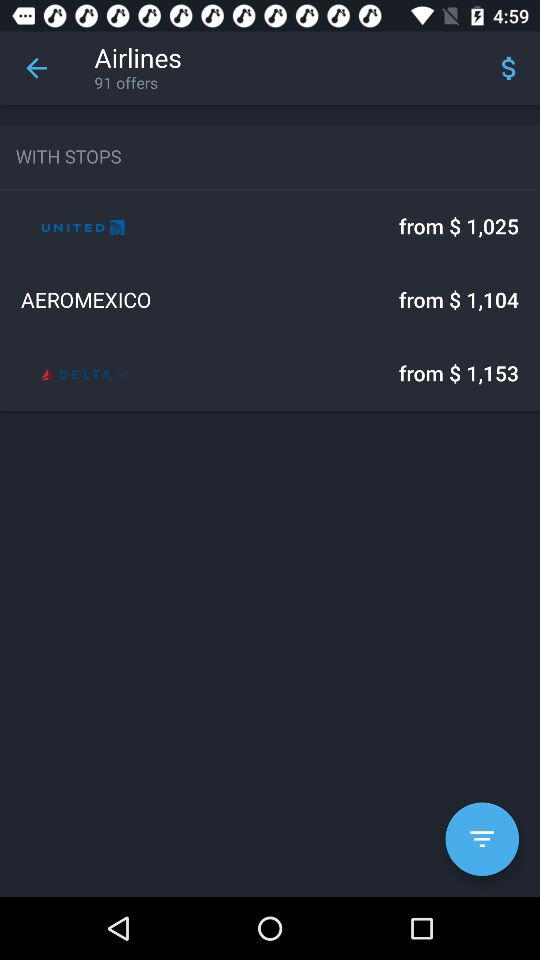What is the starting price of United Airlines? The starting price is $ 1,025. 